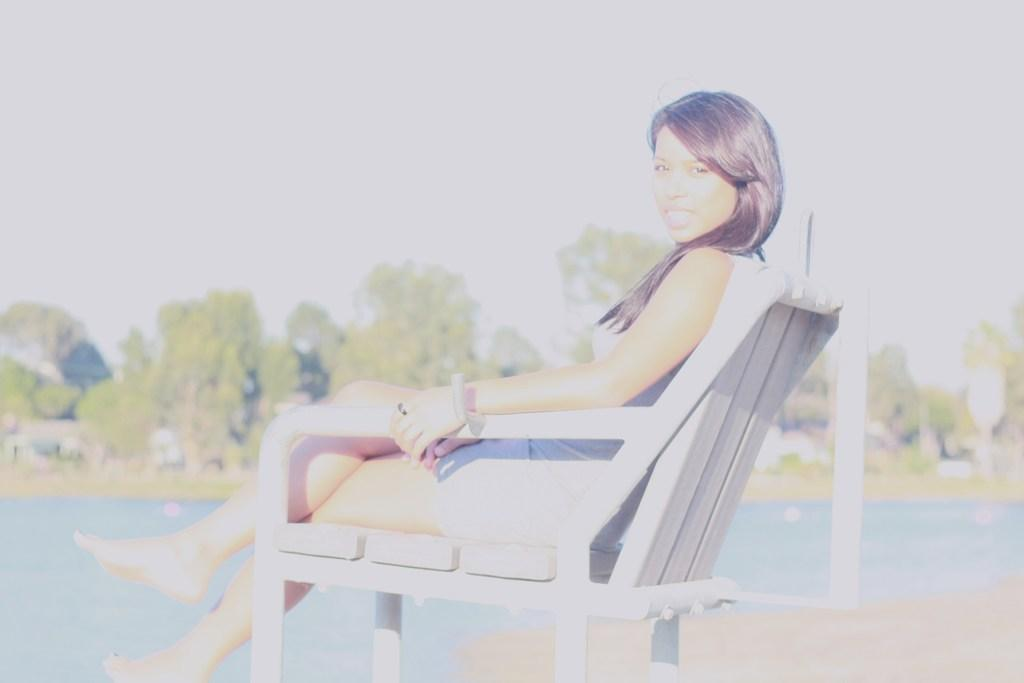What is the woman doing in the image? The woman is sitting on a chair in the image. What can be seen in the background of the image? There is water, trees, and the sky visible in the background of the image. What type of friction is the woman experiencing while sitting on the chair? The question is absurd because friction is not a type, and it is not relevant to the image. The woman is sitting on a chair, and there is no information about friction in the image. 